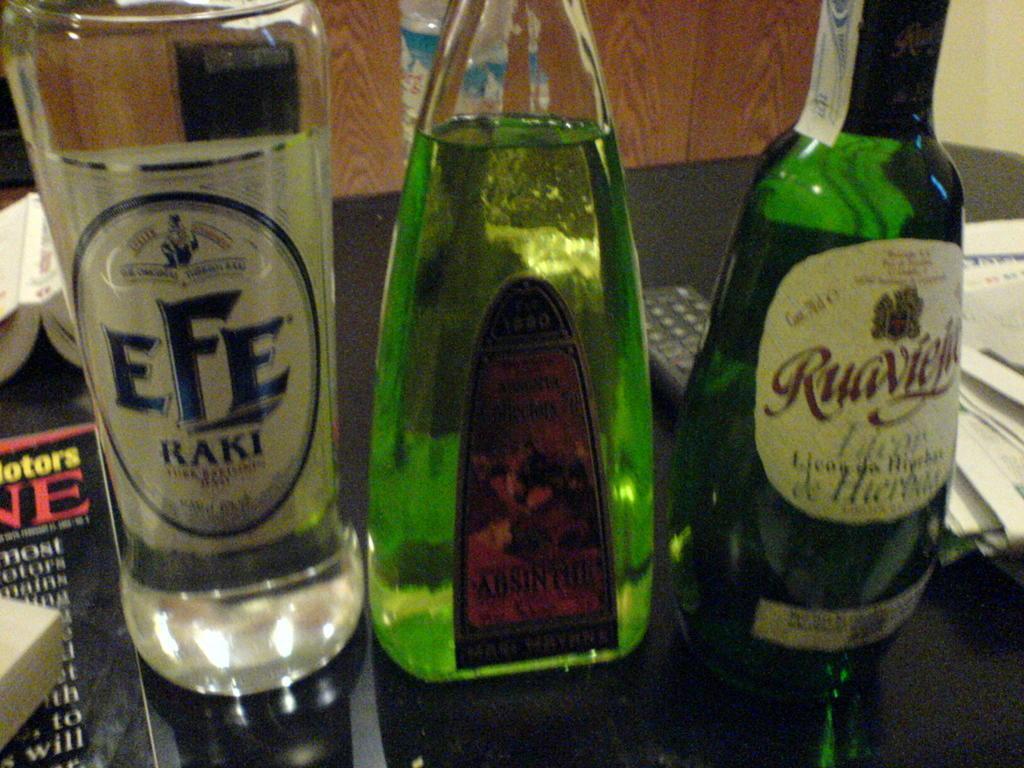Could you give a brief overview of what you see in this image? Here we can see three bottles placed on a table and there are books, papers and remote placed on it 